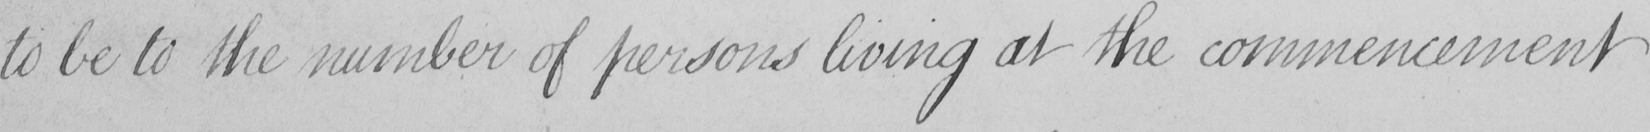What does this handwritten line say? to be to the number of persons living at the commencement 